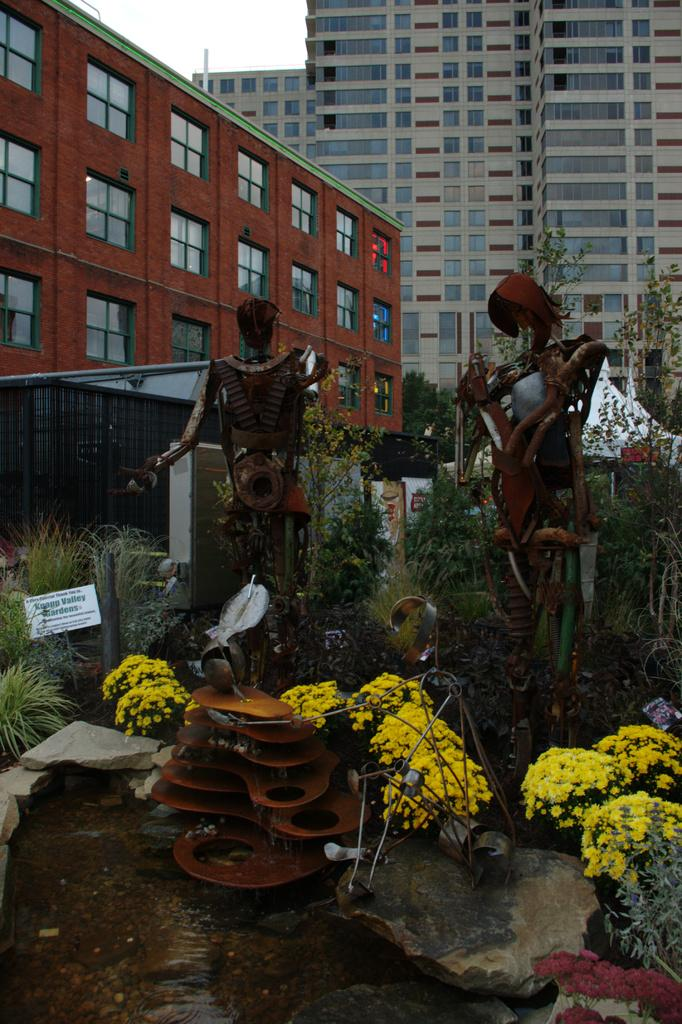What type of living organisms can be seen in the image? Plants can be seen in the image. What else is present at the bottom of the image? Other objects are present at the bottom of the image. What can be seen in the background of the image? There are buildings in the background of the image. What is visible at the top of the image? The sky is visible at the top of the image. What type of driving is being performed by the servant in the image? There is no servant or driving present in the image. What operation is being carried out by the plants in the image? Plants do not perform operations; they are living organisms that grow and produce energy through photosynthesis. 